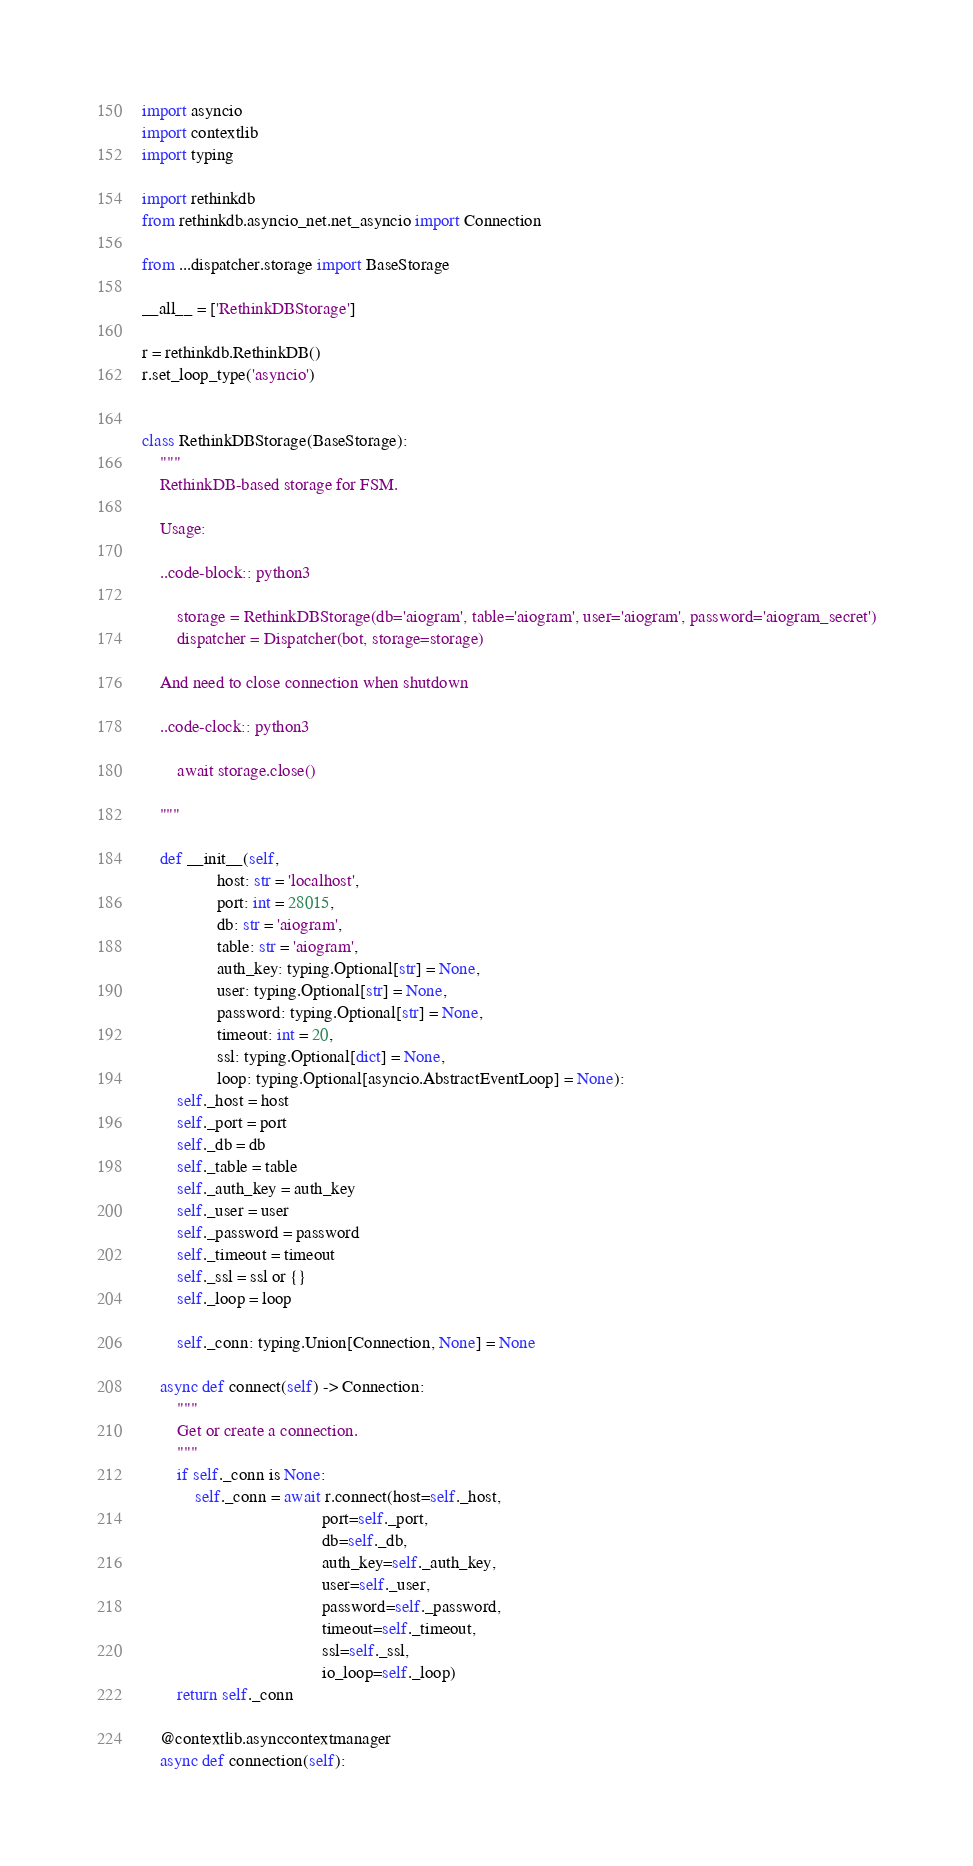Convert code to text. <code><loc_0><loc_0><loc_500><loc_500><_Python_>import asyncio
import contextlib
import typing

import rethinkdb
from rethinkdb.asyncio_net.net_asyncio import Connection

from ...dispatcher.storage import BaseStorage

__all__ = ['RethinkDBStorage']

r = rethinkdb.RethinkDB()
r.set_loop_type('asyncio')


class RethinkDBStorage(BaseStorage):
    """
    RethinkDB-based storage for FSM.

    Usage:

    ..code-block:: python3

        storage = RethinkDBStorage(db='aiogram', table='aiogram', user='aiogram', password='aiogram_secret')
        dispatcher = Dispatcher(bot, storage=storage)

    And need to close connection when shutdown

    ..code-clock:: python3

        await storage.close()

    """

    def __init__(self,
                 host: str = 'localhost',
                 port: int = 28015,
                 db: str = 'aiogram',
                 table: str = 'aiogram',
                 auth_key: typing.Optional[str] = None,
                 user: typing.Optional[str] = None,
                 password: typing.Optional[str] = None,
                 timeout: int = 20,
                 ssl: typing.Optional[dict] = None,
                 loop: typing.Optional[asyncio.AbstractEventLoop] = None):
        self._host = host
        self._port = port
        self._db = db
        self._table = table
        self._auth_key = auth_key
        self._user = user
        self._password = password
        self._timeout = timeout
        self._ssl = ssl or {}
        self._loop = loop

        self._conn: typing.Union[Connection, None] = None

    async def connect(self) -> Connection:
        """
        Get or create a connection.
        """
        if self._conn is None:
            self._conn = await r.connect(host=self._host,
                                         port=self._port,
                                         db=self._db,
                                         auth_key=self._auth_key,
                                         user=self._user,
                                         password=self._password,
                                         timeout=self._timeout,
                                         ssl=self._ssl,
                                         io_loop=self._loop)
        return self._conn

    @contextlib.asynccontextmanager
    async def connection(self):</code> 